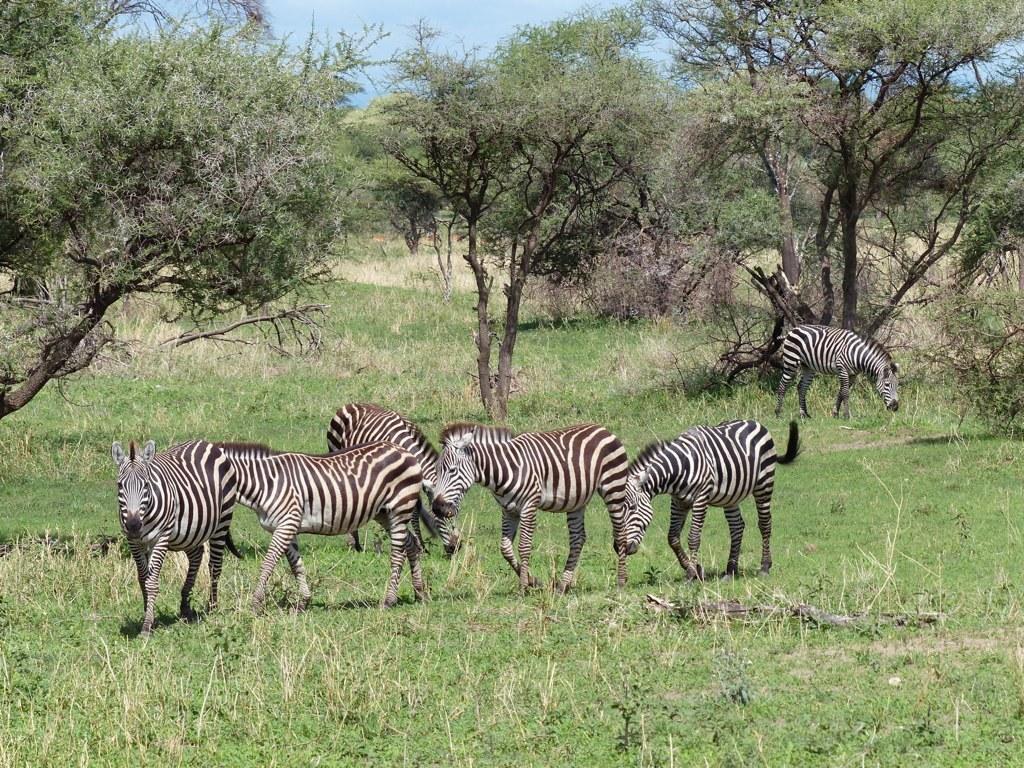Describe this image in one or two sentences. In the image we can see there are zebras standing on the ground and the ground is covered with grass and dry plants. Behind there are trees and there is a clear sky. 